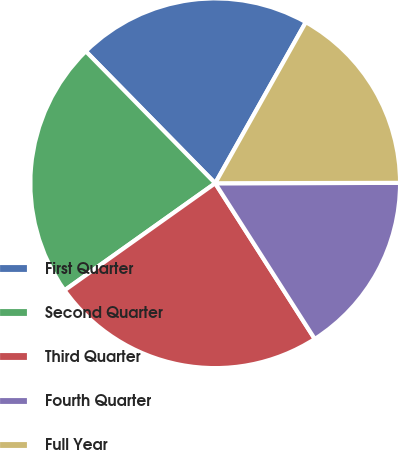Convert chart to OTSL. <chart><loc_0><loc_0><loc_500><loc_500><pie_chart><fcel>First Quarter<fcel>Second Quarter<fcel>Third Quarter<fcel>Fourth Quarter<fcel>Full Year<nl><fcel>20.5%<fcel>22.49%<fcel>24.22%<fcel>15.98%<fcel>16.81%<nl></chart> 